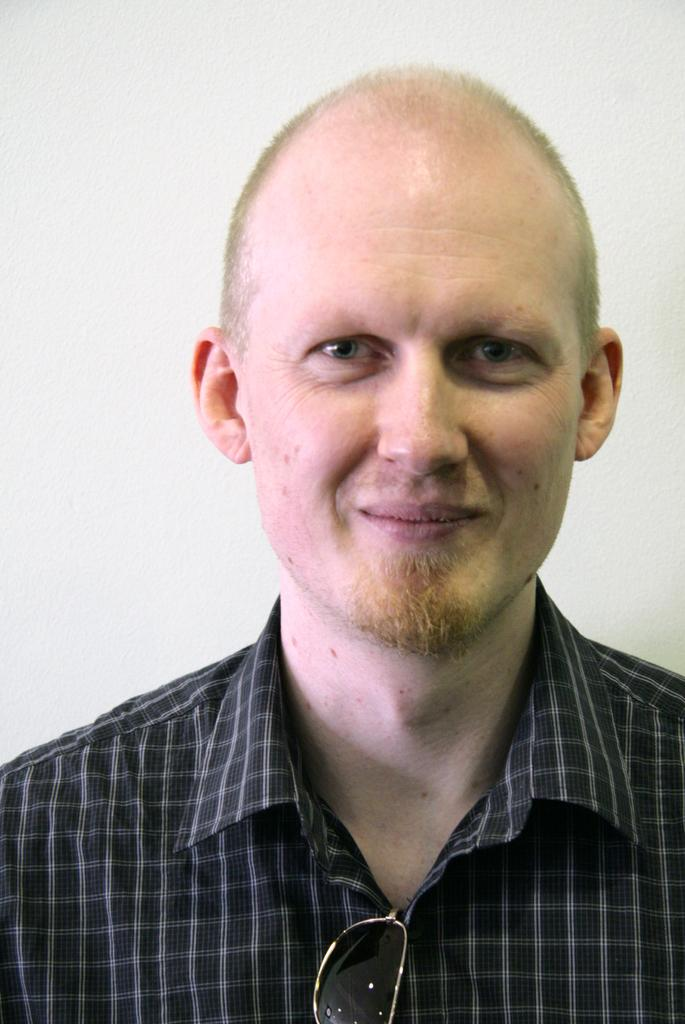What is the main subject of the image? There is a person in the image. What is the person wearing on their upper body? The person is wearing a black and white colored shirt. What type of eyewear is the person wearing? The person is wearing black colored goggles. What color is the surface in the background of the image? There is a white colored surface in the background of the image. Can you tell me how many snails are crawling on the person's shirt in the image? There are no snails present in the image; the person is wearing a black and white colored shirt. What fact can be learned about the person's goggles in the image? The fact that the person is wearing black colored goggles can be learned from the image. 